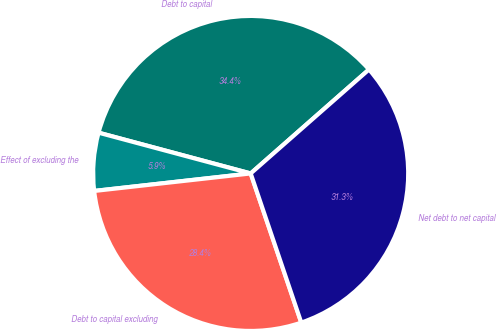Convert chart to OTSL. <chart><loc_0><loc_0><loc_500><loc_500><pie_chart><fcel>Debt to capital<fcel>Effect of excluding the<fcel>Debt to capital excluding<fcel>Net debt to net capital<nl><fcel>34.36%<fcel>5.94%<fcel>28.43%<fcel>31.27%<nl></chart> 